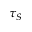Convert formula to latex. <formula><loc_0><loc_0><loc_500><loc_500>\tau _ { S }</formula> 